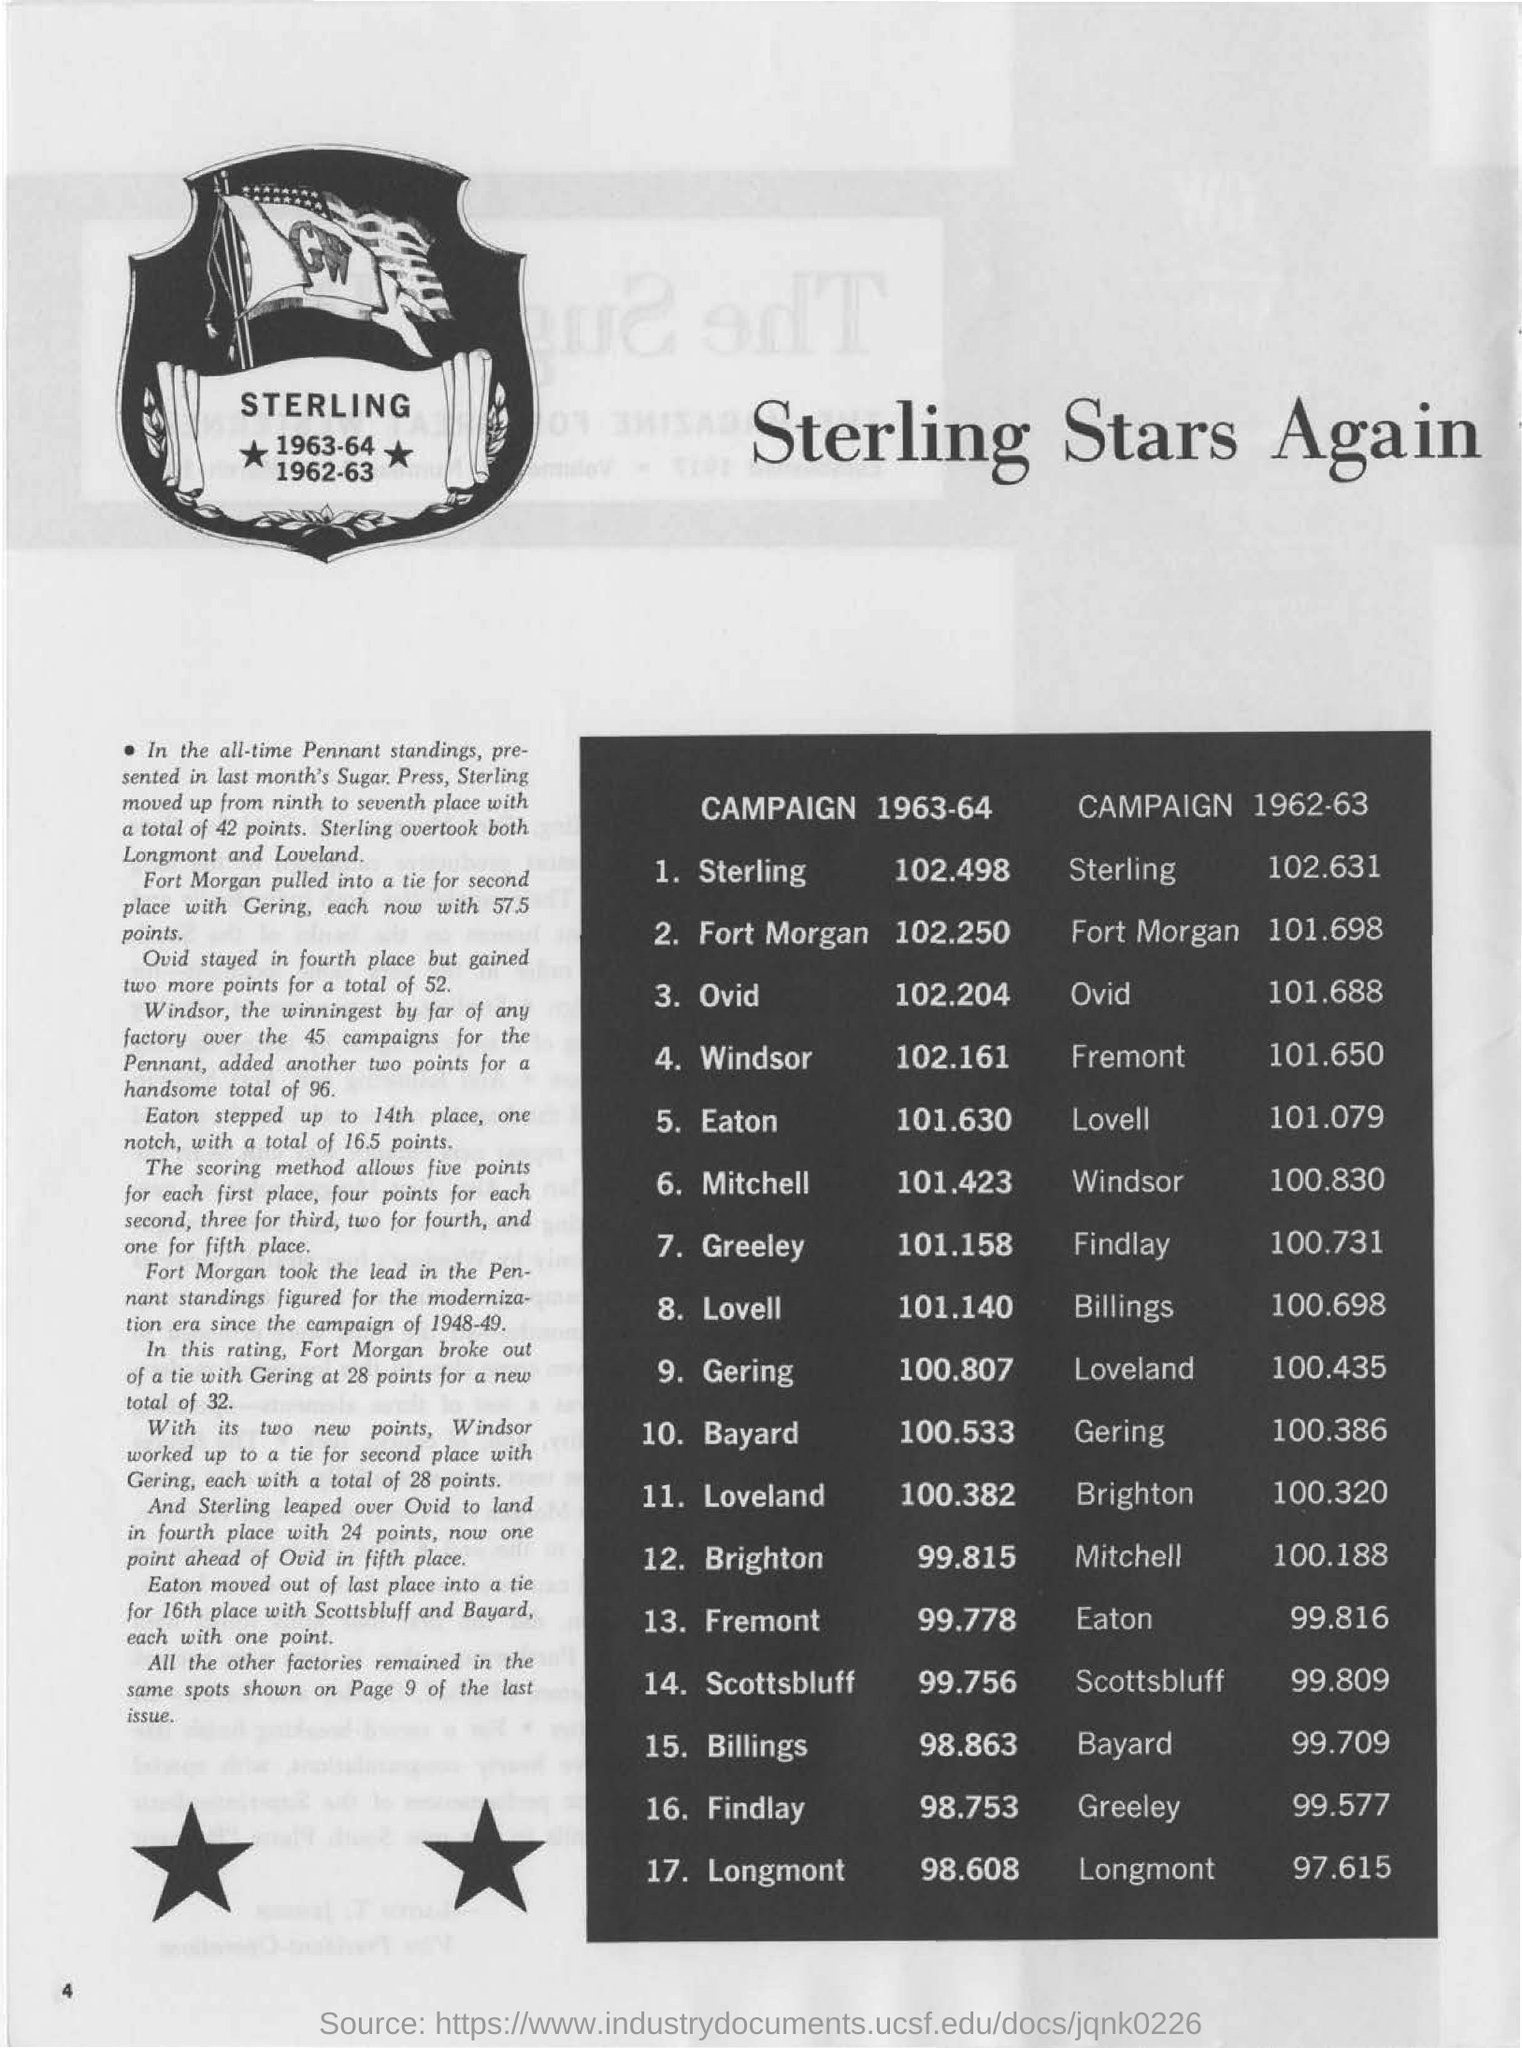Under "campaign 1963-64" how many points did fort morgan have?
Your response must be concise. 102.250. Under "campaign 1963-64" how many points did windsor have?
Offer a very short reply. 102.161. Under "campaign 1962-63" how many points did sterling have?
Make the answer very short. 102.631. Under "campaign 1962-63" how many points did mitchell have?
Your answer should be very brief. 100.188. 